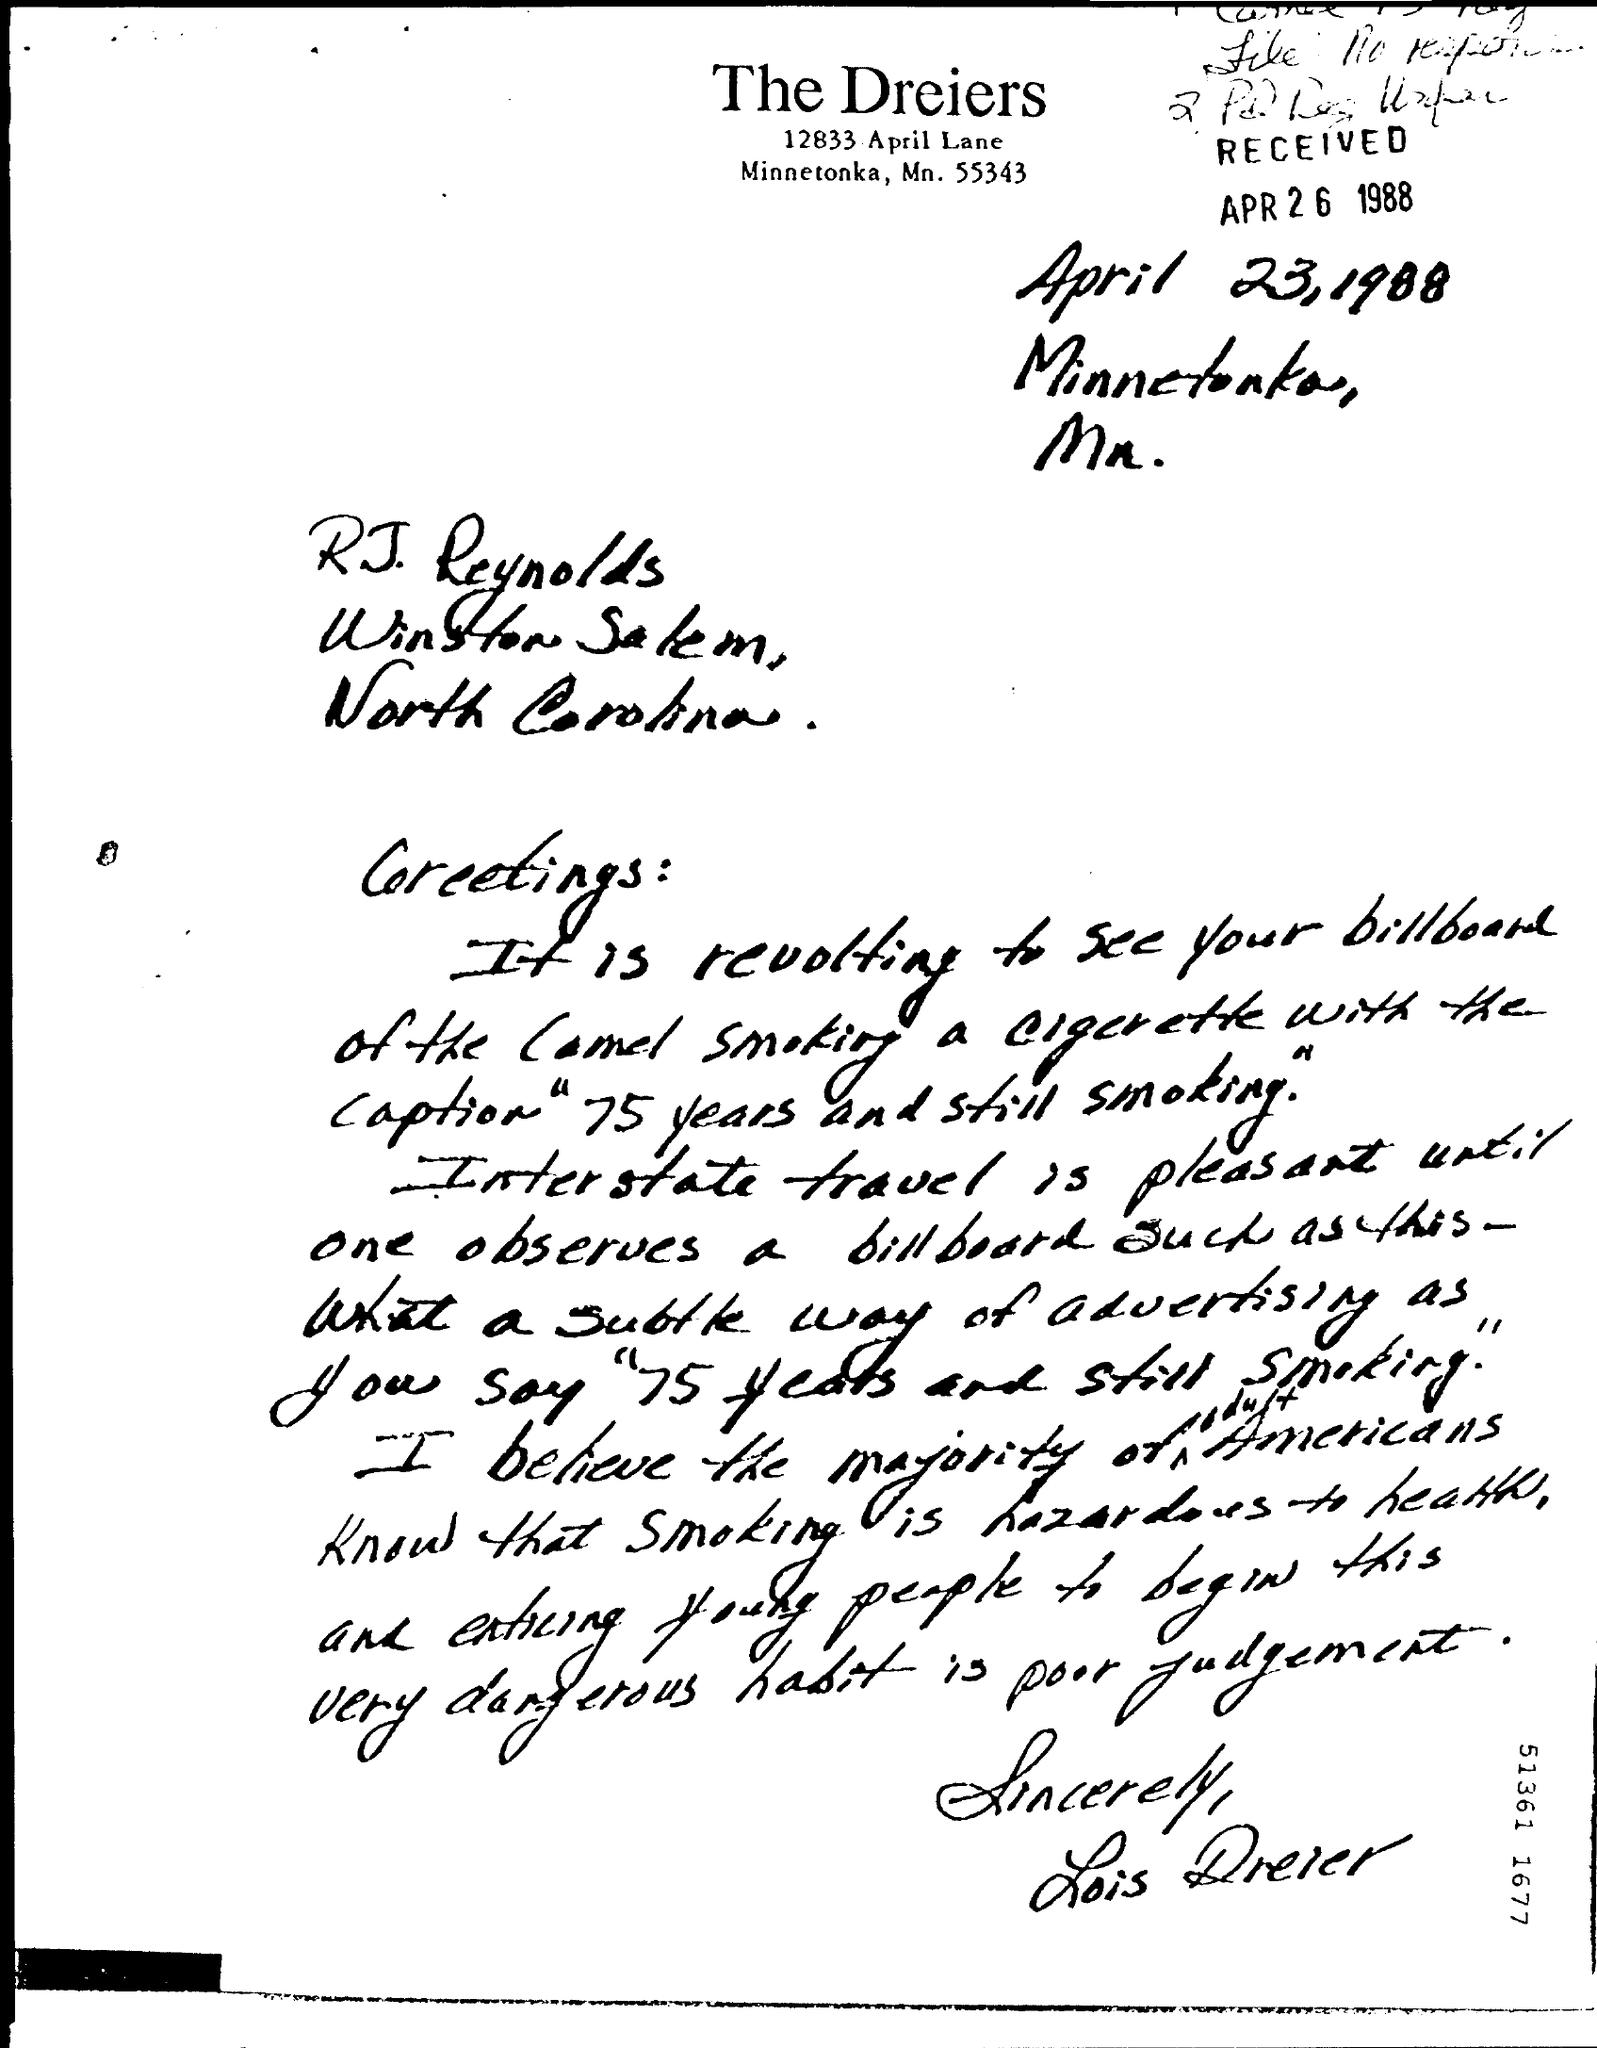On which date this letter was written ?
Your response must be concise. April 23, 1988. On which date this letter was received ?
Your answer should be very brief. APR 26 1988. Who has signed the letter at the end ?
Your answer should be very brief. LOIS DREIER. 